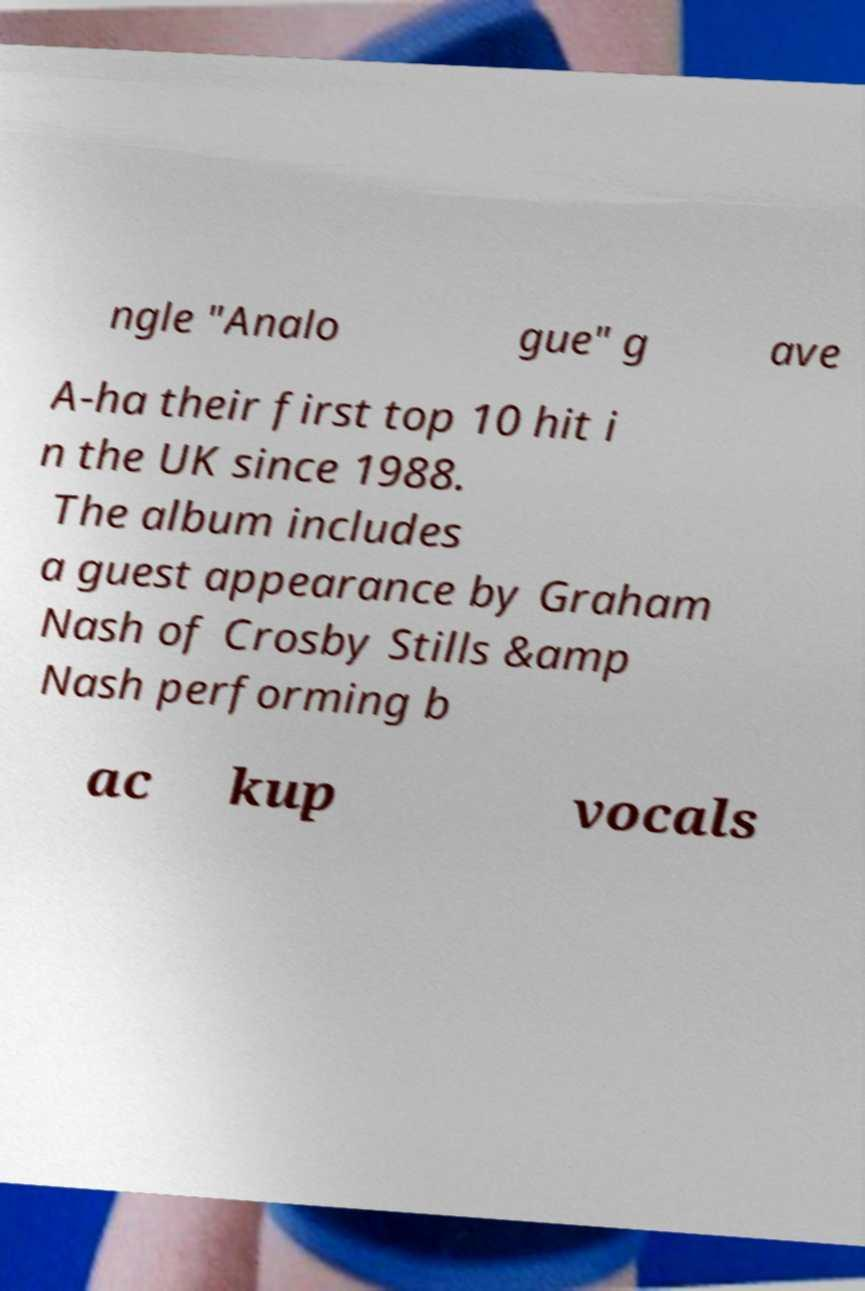Could you extract and type out the text from this image? ngle "Analo gue" g ave A-ha their first top 10 hit i n the UK since 1988. The album includes a guest appearance by Graham Nash of Crosby Stills &amp Nash performing b ac kup vocals 